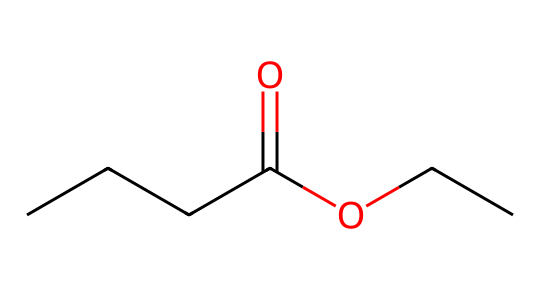What is the name of this ester? The structure represents ethyl butyrate, which is the ester formed from butanoic acid and ethanol. The presence of the butanoic acid part and the ethyl group indicates this specific combination.
Answer: ethyl butyrate How many carbon atoms are present in this molecule? Analyzing the SMILES, "CCCC" indicates there are four carbon atoms in the butanoate part, and "CC" indicates two carbon atoms in the ethyl part. Adding these gives a total of six carbon atoms.
Answer: six What type of bond is present between the carbon and oxygen in the carboxylate group? In the carboxylate group (the -C(=O)O part), the "=" indicates that there is a double bond between carbon and oxygen, characteristic of carbonyl groups.
Answer: double bond What functional group characterizes this compound as an ester? The presence of the -C(=O)O- linkage confirms it as an ester, where a carbonyl carbon is bonded to an oxygen that is also bonded to another carbon.
Answer: carboxylate What is the significance of the ethyl group in this ester? The ethyl group contributes to the overall identity and properties of the ester, particularly affecting its volatility and flavor profile, making the compound more fruity.
Answer: fruity flavor 